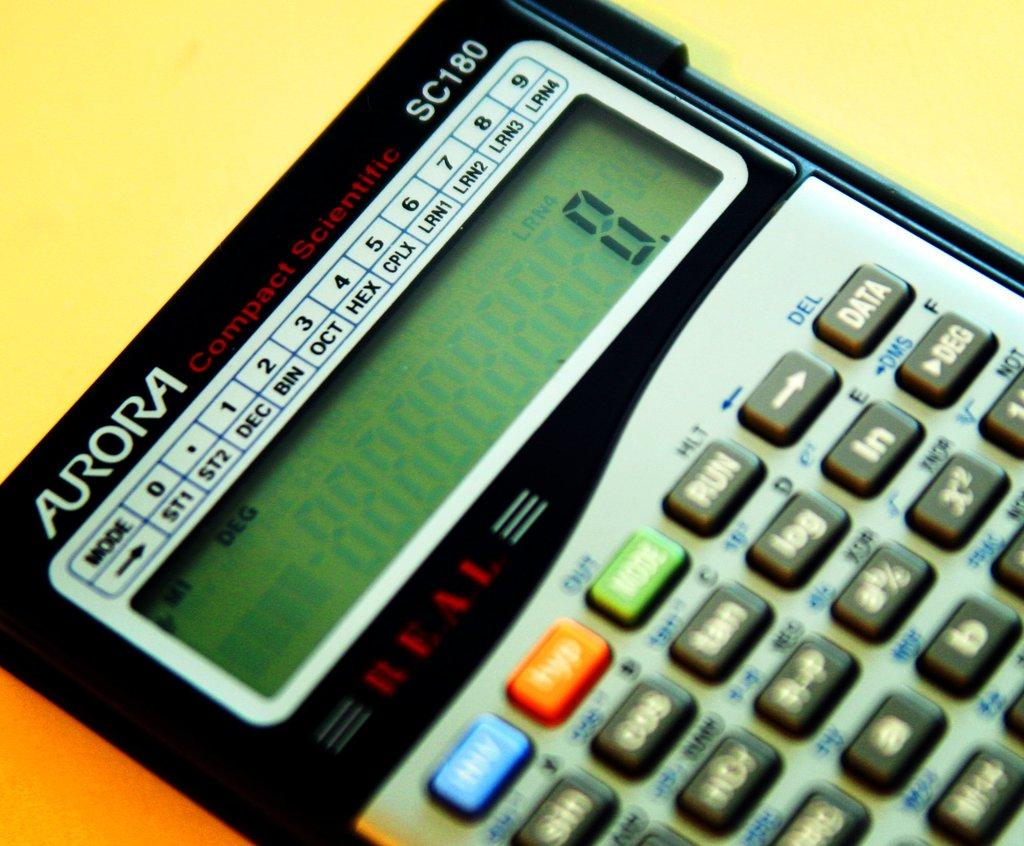Provide a one-sentence caption for the provided image. An Aurora compact scientific calculator currently reads 0. 